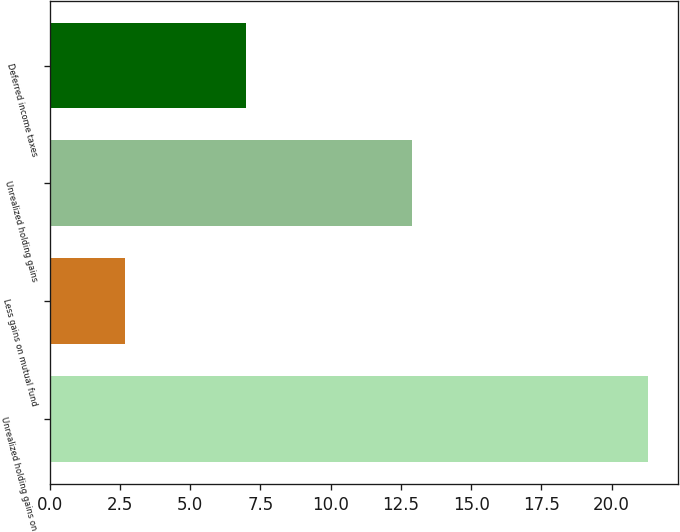Convert chart. <chart><loc_0><loc_0><loc_500><loc_500><bar_chart><fcel>Unrealized holding gains on<fcel>Less gains on mutual fund<fcel>Unrealized holding gains<fcel>Deferred income taxes<nl><fcel>21.3<fcel>2.67<fcel>12.9<fcel>7<nl></chart> 